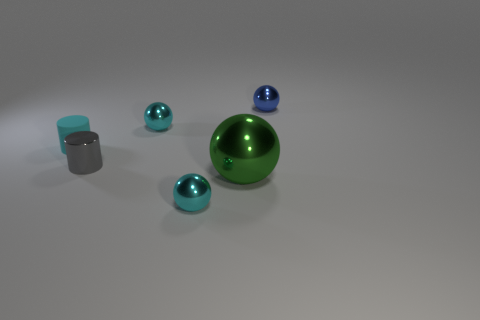Is there anything else that has the same material as the tiny cyan cylinder?
Offer a very short reply. No. How many other objects are the same color as the rubber object?
Your answer should be compact. 2. Are there any other tiny shiny objects of the same shape as the gray object?
Ensure brevity in your answer.  No. Does the small blue thing have the same material as the tiny cyan thing that is in front of the tiny gray cylinder?
Your response must be concise. Yes. What is the color of the tiny sphere in front of the cyan metallic sphere behind the cyan object that is in front of the gray metal thing?
Keep it short and to the point. Cyan. There is a gray cylinder that is the same size as the blue thing; what is it made of?
Your answer should be very brief. Metal. What number of big green balls are the same material as the cyan cylinder?
Offer a terse response. 0. There is a cyan shiny ball behind the tiny gray metal thing; does it have the same size as the cyan metal ball that is in front of the small cyan cylinder?
Offer a very short reply. Yes. The object that is on the left side of the tiny shiny cylinder is what color?
Provide a short and direct response. Cyan. How many tiny matte cylinders are the same color as the big metallic sphere?
Provide a succinct answer. 0. 